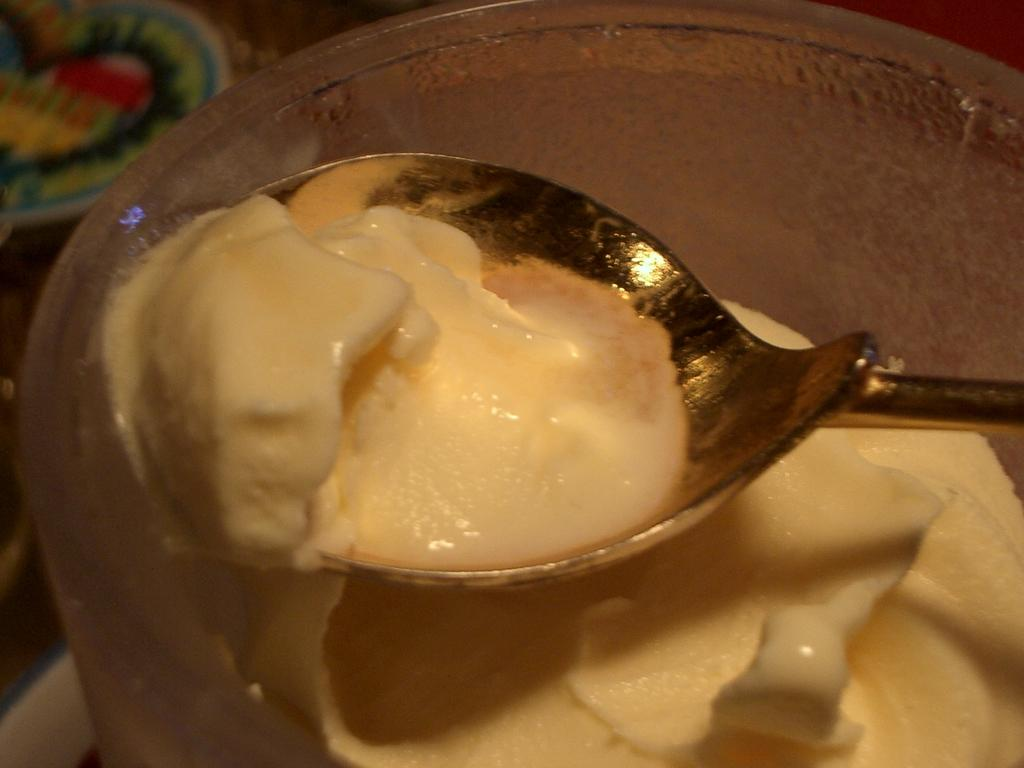What is on the spoon in the image? There is cream on a spoon in the image. What is in the bowl in the image? There is cream in a bowl in the image. Where are the spoon and bowl placed? The spoon and bowl are placed on a surface in the image. What type of basketball is being used to mix the cream in the image? There is no basketball present in the image; it features a spoon and a bowl with cream. Where are the scissors located in the image? There are no scissors present in the image. 